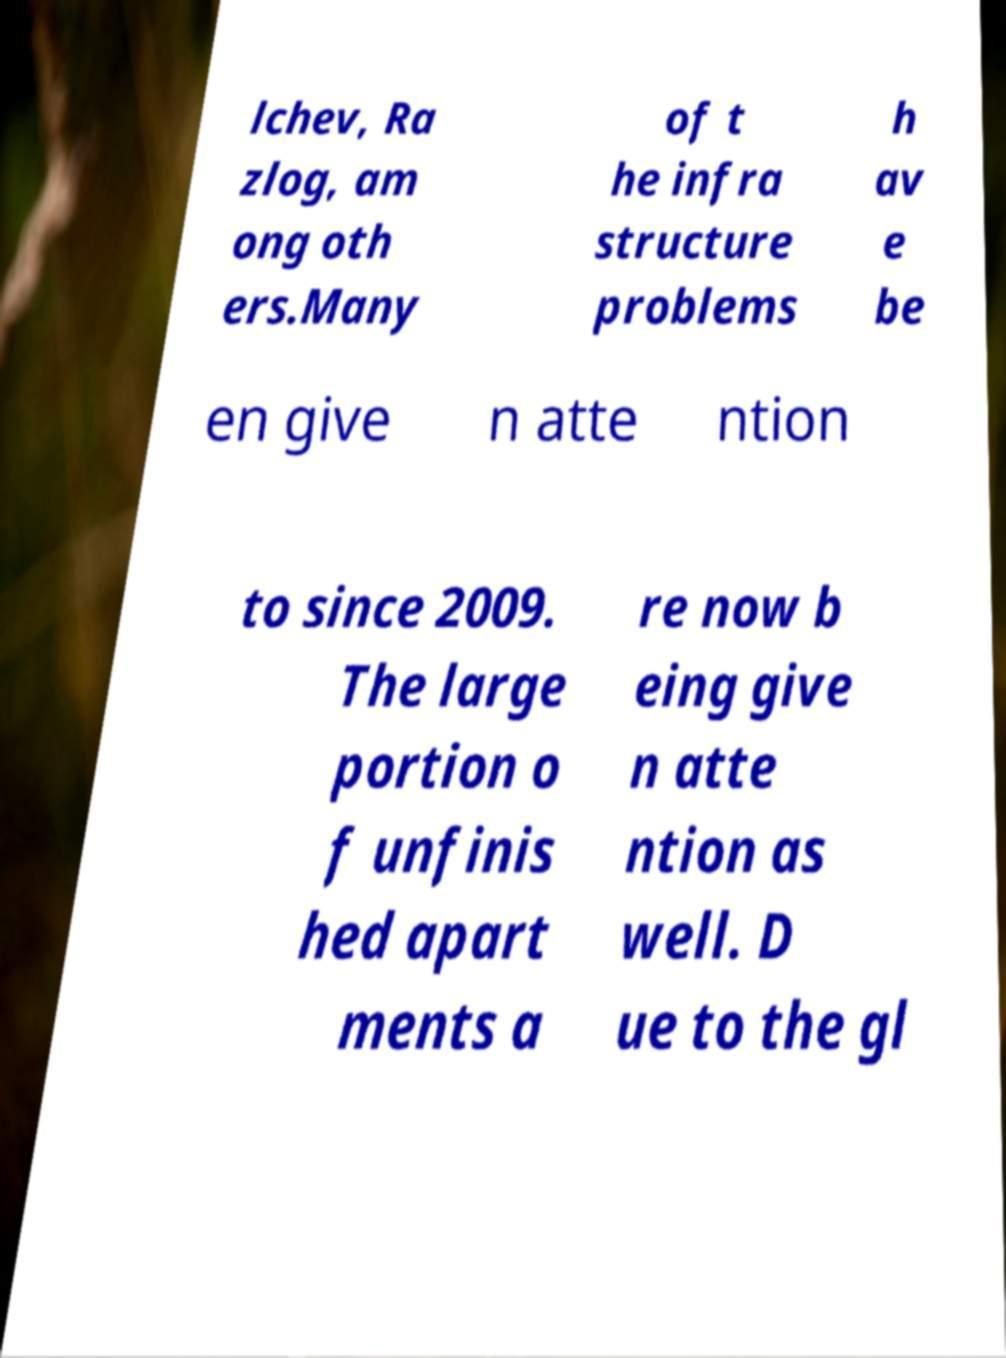Could you extract and type out the text from this image? lchev, Ra zlog, am ong oth ers.Many of t he infra structure problems h av e be en give n atte ntion to since 2009. The large portion o f unfinis hed apart ments a re now b eing give n atte ntion as well. D ue to the gl 